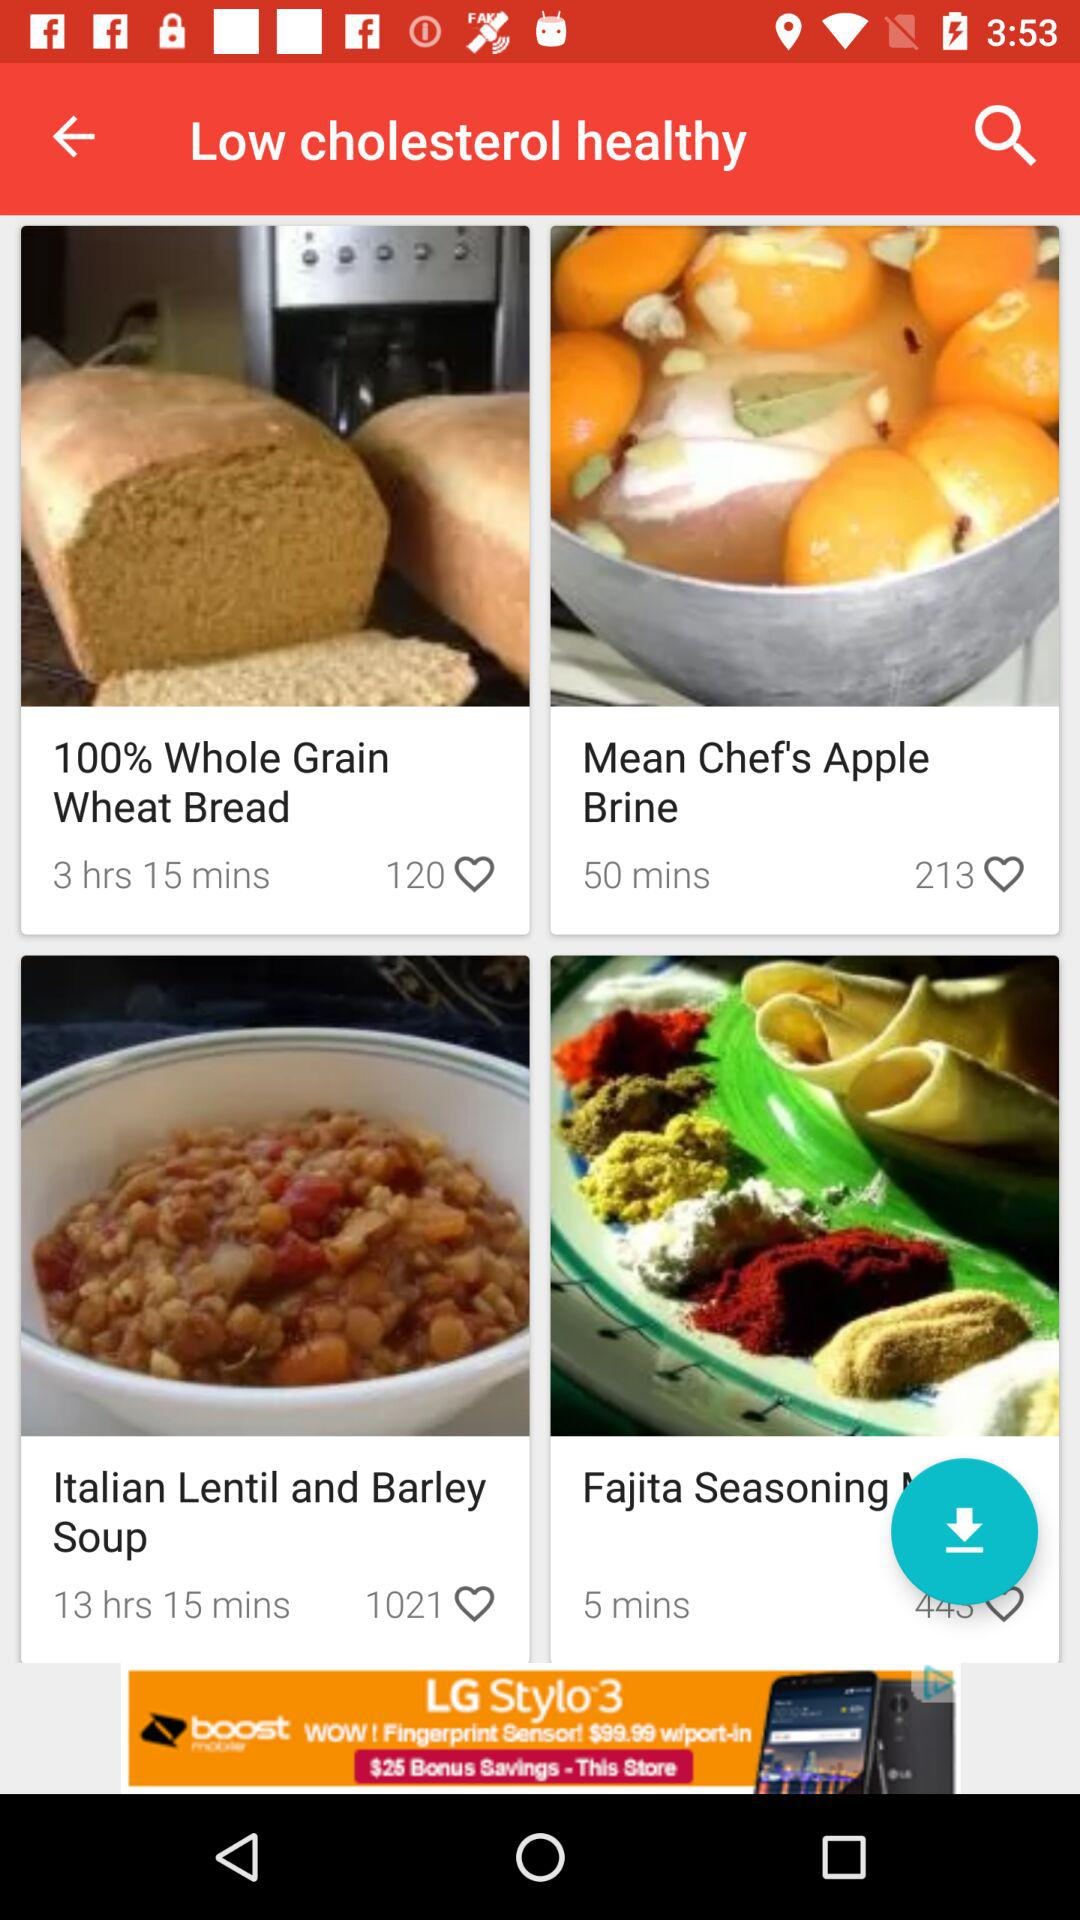What is the cooking time for Fajita Seasoning? The cooking time is 5 minutes. 